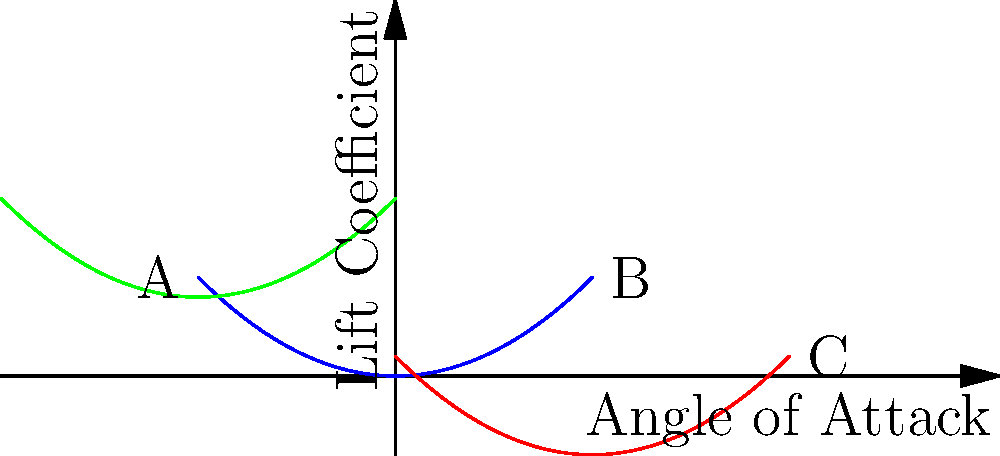Based on your understanding of airfoil behavior, which curve in the graph represents the flow pattern around an airfoil with the highest angle of attack? Explain your reasoning using principles of fluid dynamics and aerodynamics. To answer this question, we need to analyze the relationship between the angle of attack and lift coefficient for airfoils:

1. The x-axis represents the angle of attack, and the y-axis represents the lift coefficient.

2. As the angle of attack increases, the lift coefficient generally increases up to a certain point (stall angle).

3. The blue curve (A to B) shows a gradual increase in lift coefficient with increasing angle of attack.

4. The red curve (B to C) shows a steeper increase in lift coefficient, indicating a higher angle of attack.

5. The green curve is not relevant for this comparison as it's in the negative angle of attack region.

6. Among the visible curves, the red one (B to C) has the steepest slope and reaches the highest lift coefficient.

7. A steeper slope and higher maximum lift coefficient are characteristic of airfoils at higher angles of attack.

Therefore, the red curve (B to C) represents the flow pattern around an airfoil with the highest angle of attack.
Answer: The red curve (B to C) 